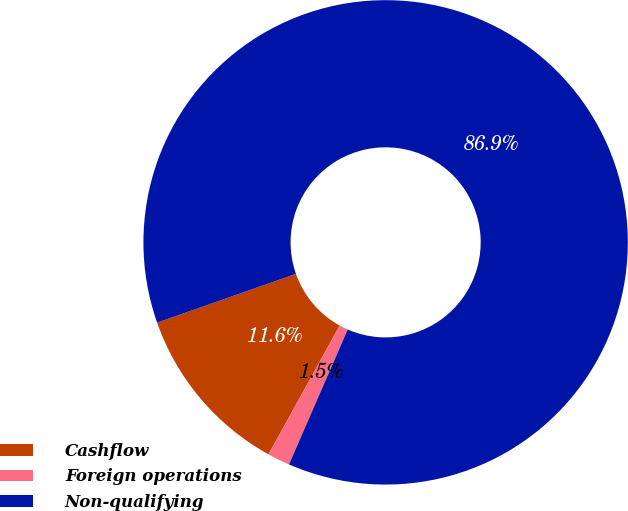Convert chart to OTSL. <chart><loc_0><loc_0><loc_500><loc_500><pie_chart><fcel>Cashflow<fcel>Foreign operations<fcel>Non-qualifying<nl><fcel>11.59%<fcel>1.5%<fcel>86.91%<nl></chart> 